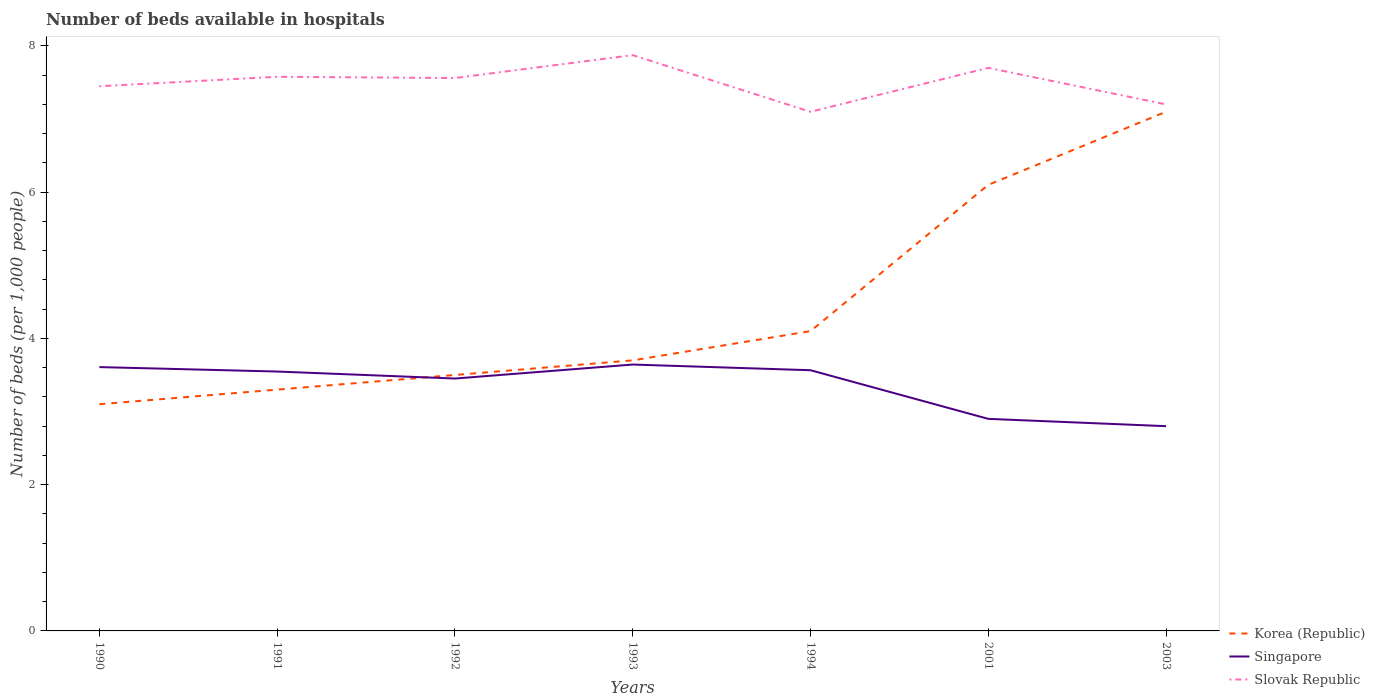How many different coloured lines are there?
Give a very brief answer. 3. Does the line corresponding to Korea (Republic) intersect with the line corresponding to Slovak Republic?
Your answer should be compact. No. Across all years, what is the maximum number of beds in the hospiatls of in Korea (Republic)?
Offer a very short reply. 3.1. In which year was the number of beds in the hospiatls of in Singapore maximum?
Provide a succinct answer. 2003. What is the total number of beds in the hospiatls of in Korea (Republic) in the graph?
Your answer should be compact. -0.8. What is the difference between the highest and the second highest number of beds in the hospiatls of in Slovak Republic?
Keep it short and to the point. 0.77. Are the values on the major ticks of Y-axis written in scientific E-notation?
Your answer should be compact. No. Does the graph contain grids?
Your response must be concise. No. Where does the legend appear in the graph?
Your response must be concise. Bottom right. How many legend labels are there?
Your answer should be very brief. 3. How are the legend labels stacked?
Give a very brief answer. Vertical. What is the title of the graph?
Provide a short and direct response. Number of beds available in hospitals. Does "Greece" appear as one of the legend labels in the graph?
Provide a succinct answer. No. What is the label or title of the X-axis?
Provide a short and direct response. Years. What is the label or title of the Y-axis?
Make the answer very short. Number of beds (per 1,0 people). What is the Number of beds (per 1,000 people) of Korea (Republic) in 1990?
Your answer should be very brief. 3.1. What is the Number of beds (per 1,000 people) of Singapore in 1990?
Offer a very short reply. 3.61. What is the Number of beds (per 1,000 people) in Slovak Republic in 1990?
Offer a terse response. 7.45. What is the Number of beds (per 1,000 people) of Korea (Republic) in 1991?
Provide a short and direct response. 3.3. What is the Number of beds (per 1,000 people) in Singapore in 1991?
Provide a short and direct response. 3.55. What is the Number of beds (per 1,000 people) in Slovak Republic in 1991?
Keep it short and to the point. 7.58. What is the Number of beds (per 1,000 people) of Korea (Republic) in 1992?
Make the answer very short. 3.5. What is the Number of beds (per 1,000 people) in Singapore in 1992?
Offer a very short reply. 3.45. What is the Number of beds (per 1,000 people) in Slovak Republic in 1992?
Your response must be concise. 7.56. What is the Number of beds (per 1,000 people) of Korea (Republic) in 1993?
Give a very brief answer. 3.7. What is the Number of beds (per 1,000 people) of Singapore in 1993?
Your answer should be compact. 3.64. What is the Number of beds (per 1,000 people) in Slovak Republic in 1993?
Give a very brief answer. 7.87. What is the Number of beds (per 1,000 people) of Korea (Republic) in 1994?
Your response must be concise. 4.1. What is the Number of beds (per 1,000 people) in Singapore in 1994?
Your answer should be very brief. 3.57. What is the Number of beds (per 1,000 people) in Slovak Republic in 1994?
Ensure brevity in your answer.  7.1. What is the Number of beds (per 1,000 people) in Korea (Republic) in 2001?
Provide a succinct answer. 6.1. What is the Number of beds (per 1,000 people) of Singapore in 2001?
Your answer should be very brief. 2.9. What is the Number of beds (per 1,000 people) of Slovak Republic in 2001?
Make the answer very short. 7.7. What is the Number of beds (per 1,000 people) in Korea (Republic) in 2003?
Make the answer very short. 7.1. What is the Number of beds (per 1,000 people) of Singapore in 2003?
Provide a short and direct response. 2.8. What is the Number of beds (per 1,000 people) of Slovak Republic in 2003?
Keep it short and to the point. 7.2. Across all years, what is the maximum Number of beds (per 1,000 people) in Korea (Republic)?
Give a very brief answer. 7.1. Across all years, what is the maximum Number of beds (per 1,000 people) of Singapore?
Your response must be concise. 3.64. Across all years, what is the maximum Number of beds (per 1,000 people) in Slovak Republic?
Your response must be concise. 7.87. Across all years, what is the minimum Number of beds (per 1,000 people) in Korea (Republic)?
Your response must be concise. 3.1. Across all years, what is the minimum Number of beds (per 1,000 people) in Singapore?
Ensure brevity in your answer.  2.8. Across all years, what is the minimum Number of beds (per 1,000 people) of Slovak Republic?
Offer a very short reply. 7.1. What is the total Number of beds (per 1,000 people) in Korea (Republic) in the graph?
Make the answer very short. 30.9. What is the total Number of beds (per 1,000 people) in Singapore in the graph?
Make the answer very short. 23.51. What is the total Number of beds (per 1,000 people) of Slovak Republic in the graph?
Keep it short and to the point. 52.46. What is the difference between the Number of beds (per 1,000 people) of Singapore in 1990 and that in 1991?
Your answer should be compact. 0.06. What is the difference between the Number of beds (per 1,000 people) in Slovak Republic in 1990 and that in 1991?
Your answer should be compact. -0.13. What is the difference between the Number of beds (per 1,000 people) in Singapore in 1990 and that in 1992?
Your answer should be very brief. 0.16. What is the difference between the Number of beds (per 1,000 people) of Slovak Republic in 1990 and that in 1992?
Provide a succinct answer. -0.11. What is the difference between the Number of beds (per 1,000 people) of Korea (Republic) in 1990 and that in 1993?
Offer a terse response. -0.6. What is the difference between the Number of beds (per 1,000 people) of Singapore in 1990 and that in 1993?
Offer a terse response. -0.03. What is the difference between the Number of beds (per 1,000 people) in Slovak Republic in 1990 and that in 1993?
Your answer should be very brief. -0.43. What is the difference between the Number of beds (per 1,000 people) in Singapore in 1990 and that in 1994?
Keep it short and to the point. 0.04. What is the difference between the Number of beds (per 1,000 people) in Slovak Republic in 1990 and that in 1994?
Offer a very short reply. 0.35. What is the difference between the Number of beds (per 1,000 people) in Singapore in 1990 and that in 2001?
Provide a short and direct response. 0.71. What is the difference between the Number of beds (per 1,000 people) of Slovak Republic in 1990 and that in 2001?
Give a very brief answer. -0.25. What is the difference between the Number of beds (per 1,000 people) of Singapore in 1990 and that in 2003?
Provide a short and direct response. 0.81. What is the difference between the Number of beds (per 1,000 people) in Slovak Republic in 1990 and that in 2003?
Offer a terse response. 0.25. What is the difference between the Number of beds (per 1,000 people) in Singapore in 1991 and that in 1992?
Keep it short and to the point. 0.1. What is the difference between the Number of beds (per 1,000 people) of Slovak Republic in 1991 and that in 1992?
Keep it short and to the point. 0.02. What is the difference between the Number of beds (per 1,000 people) in Korea (Republic) in 1991 and that in 1993?
Make the answer very short. -0.4. What is the difference between the Number of beds (per 1,000 people) in Singapore in 1991 and that in 1993?
Give a very brief answer. -0.1. What is the difference between the Number of beds (per 1,000 people) of Slovak Republic in 1991 and that in 1993?
Your answer should be very brief. -0.3. What is the difference between the Number of beds (per 1,000 people) in Singapore in 1991 and that in 1994?
Ensure brevity in your answer.  -0.02. What is the difference between the Number of beds (per 1,000 people) in Slovak Republic in 1991 and that in 1994?
Provide a succinct answer. 0.48. What is the difference between the Number of beds (per 1,000 people) in Singapore in 1991 and that in 2001?
Offer a very short reply. 0.65. What is the difference between the Number of beds (per 1,000 people) in Slovak Republic in 1991 and that in 2001?
Your answer should be compact. -0.12. What is the difference between the Number of beds (per 1,000 people) of Korea (Republic) in 1991 and that in 2003?
Provide a succinct answer. -3.8. What is the difference between the Number of beds (per 1,000 people) in Singapore in 1991 and that in 2003?
Keep it short and to the point. 0.75. What is the difference between the Number of beds (per 1,000 people) of Slovak Republic in 1991 and that in 2003?
Provide a short and direct response. 0.38. What is the difference between the Number of beds (per 1,000 people) of Korea (Republic) in 1992 and that in 1993?
Your answer should be compact. -0.2. What is the difference between the Number of beds (per 1,000 people) in Singapore in 1992 and that in 1993?
Make the answer very short. -0.19. What is the difference between the Number of beds (per 1,000 people) in Slovak Republic in 1992 and that in 1993?
Provide a short and direct response. -0.31. What is the difference between the Number of beds (per 1,000 people) of Singapore in 1992 and that in 1994?
Provide a succinct answer. -0.11. What is the difference between the Number of beds (per 1,000 people) of Slovak Republic in 1992 and that in 1994?
Provide a short and direct response. 0.46. What is the difference between the Number of beds (per 1,000 people) of Singapore in 1992 and that in 2001?
Provide a succinct answer. 0.55. What is the difference between the Number of beds (per 1,000 people) in Slovak Republic in 1992 and that in 2001?
Provide a succinct answer. -0.14. What is the difference between the Number of beds (per 1,000 people) in Korea (Republic) in 1992 and that in 2003?
Keep it short and to the point. -3.6. What is the difference between the Number of beds (per 1,000 people) of Singapore in 1992 and that in 2003?
Your answer should be compact. 0.65. What is the difference between the Number of beds (per 1,000 people) in Slovak Republic in 1992 and that in 2003?
Make the answer very short. 0.36. What is the difference between the Number of beds (per 1,000 people) in Singapore in 1993 and that in 1994?
Offer a very short reply. 0.08. What is the difference between the Number of beds (per 1,000 people) in Slovak Republic in 1993 and that in 1994?
Your answer should be very brief. 0.77. What is the difference between the Number of beds (per 1,000 people) in Singapore in 1993 and that in 2001?
Give a very brief answer. 0.74. What is the difference between the Number of beds (per 1,000 people) of Slovak Republic in 1993 and that in 2001?
Provide a succinct answer. 0.17. What is the difference between the Number of beds (per 1,000 people) in Korea (Republic) in 1993 and that in 2003?
Make the answer very short. -3.4. What is the difference between the Number of beds (per 1,000 people) in Singapore in 1993 and that in 2003?
Make the answer very short. 0.84. What is the difference between the Number of beds (per 1,000 people) of Slovak Republic in 1993 and that in 2003?
Keep it short and to the point. 0.67. What is the difference between the Number of beds (per 1,000 people) of Singapore in 1994 and that in 2001?
Provide a short and direct response. 0.67. What is the difference between the Number of beds (per 1,000 people) of Slovak Republic in 1994 and that in 2001?
Keep it short and to the point. -0.6. What is the difference between the Number of beds (per 1,000 people) in Korea (Republic) in 1994 and that in 2003?
Provide a succinct answer. -3. What is the difference between the Number of beds (per 1,000 people) in Singapore in 1994 and that in 2003?
Your answer should be very brief. 0.77. What is the difference between the Number of beds (per 1,000 people) in Slovak Republic in 1994 and that in 2003?
Provide a succinct answer. -0.1. What is the difference between the Number of beds (per 1,000 people) in Korea (Republic) in 2001 and that in 2003?
Make the answer very short. -1. What is the difference between the Number of beds (per 1,000 people) in Korea (Republic) in 1990 and the Number of beds (per 1,000 people) in Singapore in 1991?
Make the answer very short. -0.45. What is the difference between the Number of beds (per 1,000 people) in Korea (Republic) in 1990 and the Number of beds (per 1,000 people) in Slovak Republic in 1991?
Your response must be concise. -4.48. What is the difference between the Number of beds (per 1,000 people) in Singapore in 1990 and the Number of beds (per 1,000 people) in Slovak Republic in 1991?
Make the answer very short. -3.97. What is the difference between the Number of beds (per 1,000 people) of Korea (Republic) in 1990 and the Number of beds (per 1,000 people) of Singapore in 1992?
Offer a terse response. -0.35. What is the difference between the Number of beds (per 1,000 people) in Korea (Republic) in 1990 and the Number of beds (per 1,000 people) in Slovak Republic in 1992?
Give a very brief answer. -4.46. What is the difference between the Number of beds (per 1,000 people) of Singapore in 1990 and the Number of beds (per 1,000 people) of Slovak Republic in 1992?
Your answer should be very brief. -3.95. What is the difference between the Number of beds (per 1,000 people) in Korea (Republic) in 1990 and the Number of beds (per 1,000 people) in Singapore in 1993?
Ensure brevity in your answer.  -0.54. What is the difference between the Number of beds (per 1,000 people) of Korea (Republic) in 1990 and the Number of beds (per 1,000 people) of Slovak Republic in 1993?
Make the answer very short. -4.77. What is the difference between the Number of beds (per 1,000 people) of Singapore in 1990 and the Number of beds (per 1,000 people) of Slovak Republic in 1993?
Your response must be concise. -4.27. What is the difference between the Number of beds (per 1,000 people) in Korea (Republic) in 1990 and the Number of beds (per 1,000 people) in Singapore in 1994?
Offer a terse response. -0.47. What is the difference between the Number of beds (per 1,000 people) of Korea (Republic) in 1990 and the Number of beds (per 1,000 people) of Slovak Republic in 1994?
Ensure brevity in your answer.  -4. What is the difference between the Number of beds (per 1,000 people) of Singapore in 1990 and the Number of beds (per 1,000 people) of Slovak Republic in 1994?
Ensure brevity in your answer.  -3.49. What is the difference between the Number of beds (per 1,000 people) in Singapore in 1990 and the Number of beds (per 1,000 people) in Slovak Republic in 2001?
Keep it short and to the point. -4.09. What is the difference between the Number of beds (per 1,000 people) in Korea (Republic) in 1990 and the Number of beds (per 1,000 people) in Singapore in 2003?
Offer a very short reply. 0.3. What is the difference between the Number of beds (per 1,000 people) of Singapore in 1990 and the Number of beds (per 1,000 people) of Slovak Republic in 2003?
Your answer should be very brief. -3.59. What is the difference between the Number of beds (per 1,000 people) in Korea (Republic) in 1991 and the Number of beds (per 1,000 people) in Singapore in 1992?
Ensure brevity in your answer.  -0.15. What is the difference between the Number of beds (per 1,000 people) in Korea (Republic) in 1991 and the Number of beds (per 1,000 people) in Slovak Republic in 1992?
Ensure brevity in your answer.  -4.26. What is the difference between the Number of beds (per 1,000 people) of Singapore in 1991 and the Number of beds (per 1,000 people) of Slovak Republic in 1992?
Your answer should be very brief. -4.01. What is the difference between the Number of beds (per 1,000 people) of Korea (Republic) in 1991 and the Number of beds (per 1,000 people) of Singapore in 1993?
Ensure brevity in your answer.  -0.34. What is the difference between the Number of beds (per 1,000 people) in Korea (Republic) in 1991 and the Number of beds (per 1,000 people) in Slovak Republic in 1993?
Ensure brevity in your answer.  -4.57. What is the difference between the Number of beds (per 1,000 people) of Singapore in 1991 and the Number of beds (per 1,000 people) of Slovak Republic in 1993?
Keep it short and to the point. -4.33. What is the difference between the Number of beds (per 1,000 people) of Korea (Republic) in 1991 and the Number of beds (per 1,000 people) of Singapore in 1994?
Your answer should be very brief. -0.27. What is the difference between the Number of beds (per 1,000 people) in Korea (Republic) in 1991 and the Number of beds (per 1,000 people) in Slovak Republic in 1994?
Offer a terse response. -3.8. What is the difference between the Number of beds (per 1,000 people) in Singapore in 1991 and the Number of beds (per 1,000 people) in Slovak Republic in 1994?
Make the answer very short. -3.55. What is the difference between the Number of beds (per 1,000 people) in Korea (Republic) in 1991 and the Number of beds (per 1,000 people) in Singapore in 2001?
Keep it short and to the point. 0.4. What is the difference between the Number of beds (per 1,000 people) of Singapore in 1991 and the Number of beds (per 1,000 people) of Slovak Republic in 2001?
Your answer should be compact. -4.15. What is the difference between the Number of beds (per 1,000 people) in Korea (Republic) in 1991 and the Number of beds (per 1,000 people) in Singapore in 2003?
Make the answer very short. 0.5. What is the difference between the Number of beds (per 1,000 people) in Singapore in 1991 and the Number of beds (per 1,000 people) in Slovak Republic in 2003?
Give a very brief answer. -3.65. What is the difference between the Number of beds (per 1,000 people) of Korea (Republic) in 1992 and the Number of beds (per 1,000 people) of Singapore in 1993?
Your answer should be very brief. -0.14. What is the difference between the Number of beds (per 1,000 people) of Korea (Republic) in 1992 and the Number of beds (per 1,000 people) of Slovak Republic in 1993?
Provide a short and direct response. -4.37. What is the difference between the Number of beds (per 1,000 people) of Singapore in 1992 and the Number of beds (per 1,000 people) of Slovak Republic in 1993?
Offer a very short reply. -4.42. What is the difference between the Number of beds (per 1,000 people) of Korea (Republic) in 1992 and the Number of beds (per 1,000 people) of Singapore in 1994?
Provide a short and direct response. -0.07. What is the difference between the Number of beds (per 1,000 people) in Korea (Republic) in 1992 and the Number of beds (per 1,000 people) in Slovak Republic in 1994?
Your answer should be very brief. -3.6. What is the difference between the Number of beds (per 1,000 people) of Singapore in 1992 and the Number of beds (per 1,000 people) of Slovak Republic in 1994?
Ensure brevity in your answer.  -3.65. What is the difference between the Number of beds (per 1,000 people) in Korea (Republic) in 1992 and the Number of beds (per 1,000 people) in Singapore in 2001?
Make the answer very short. 0.6. What is the difference between the Number of beds (per 1,000 people) in Korea (Republic) in 1992 and the Number of beds (per 1,000 people) in Slovak Republic in 2001?
Your response must be concise. -4.2. What is the difference between the Number of beds (per 1,000 people) in Singapore in 1992 and the Number of beds (per 1,000 people) in Slovak Republic in 2001?
Keep it short and to the point. -4.25. What is the difference between the Number of beds (per 1,000 people) in Singapore in 1992 and the Number of beds (per 1,000 people) in Slovak Republic in 2003?
Your answer should be very brief. -3.75. What is the difference between the Number of beds (per 1,000 people) in Korea (Republic) in 1993 and the Number of beds (per 1,000 people) in Singapore in 1994?
Provide a short and direct response. 0.13. What is the difference between the Number of beds (per 1,000 people) in Korea (Republic) in 1993 and the Number of beds (per 1,000 people) in Slovak Republic in 1994?
Your answer should be compact. -3.4. What is the difference between the Number of beds (per 1,000 people) in Singapore in 1993 and the Number of beds (per 1,000 people) in Slovak Republic in 1994?
Your answer should be compact. -3.46. What is the difference between the Number of beds (per 1,000 people) in Korea (Republic) in 1993 and the Number of beds (per 1,000 people) in Singapore in 2001?
Offer a terse response. 0.8. What is the difference between the Number of beds (per 1,000 people) of Korea (Republic) in 1993 and the Number of beds (per 1,000 people) of Slovak Republic in 2001?
Provide a succinct answer. -4. What is the difference between the Number of beds (per 1,000 people) of Singapore in 1993 and the Number of beds (per 1,000 people) of Slovak Republic in 2001?
Your response must be concise. -4.06. What is the difference between the Number of beds (per 1,000 people) in Korea (Republic) in 1993 and the Number of beds (per 1,000 people) in Singapore in 2003?
Provide a succinct answer. 0.9. What is the difference between the Number of beds (per 1,000 people) of Korea (Republic) in 1993 and the Number of beds (per 1,000 people) of Slovak Republic in 2003?
Keep it short and to the point. -3.5. What is the difference between the Number of beds (per 1,000 people) in Singapore in 1993 and the Number of beds (per 1,000 people) in Slovak Republic in 2003?
Offer a terse response. -3.56. What is the difference between the Number of beds (per 1,000 people) of Korea (Republic) in 1994 and the Number of beds (per 1,000 people) of Slovak Republic in 2001?
Give a very brief answer. -3.6. What is the difference between the Number of beds (per 1,000 people) in Singapore in 1994 and the Number of beds (per 1,000 people) in Slovak Republic in 2001?
Give a very brief answer. -4.13. What is the difference between the Number of beds (per 1,000 people) of Singapore in 1994 and the Number of beds (per 1,000 people) of Slovak Republic in 2003?
Your answer should be compact. -3.63. What is the difference between the Number of beds (per 1,000 people) in Korea (Republic) in 2001 and the Number of beds (per 1,000 people) in Slovak Republic in 2003?
Give a very brief answer. -1.1. What is the average Number of beds (per 1,000 people) in Korea (Republic) per year?
Offer a terse response. 4.41. What is the average Number of beds (per 1,000 people) of Singapore per year?
Provide a short and direct response. 3.36. What is the average Number of beds (per 1,000 people) in Slovak Republic per year?
Provide a short and direct response. 7.49. In the year 1990, what is the difference between the Number of beds (per 1,000 people) of Korea (Republic) and Number of beds (per 1,000 people) of Singapore?
Offer a very short reply. -0.51. In the year 1990, what is the difference between the Number of beds (per 1,000 people) of Korea (Republic) and Number of beds (per 1,000 people) of Slovak Republic?
Keep it short and to the point. -4.35. In the year 1990, what is the difference between the Number of beds (per 1,000 people) in Singapore and Number of beds (per 1,000 people) in Slovak Republic?
Your answer should be very brief. -3.84. In the year 1991, what is the difference between the Number of beds (per 1,000 people) in Korea (Republic) and Number of beds (per 1,000 people) in Singapore?
Provide a succinct answer. -0.25. In the year 1991, what is the difference between the Number of beds (per 1,000 people) in Korea (Republic) and Number of beds (per 1,000 people) in Slovak Republic?
Ensure brevity in your answer.  -4.28. In the year 1991, what is the difference between the Number of beds (per 1,000 people) of Singapore and Number of beds (per 1,000 people) of Slovak Republic?
Your answer should be compact. -4.03. In the year 1992, what is the difference between the Number of beds (per 1,000 people) in Korea (Republic) and Number of beds (per 1,000 people) in Singapore?
Make the answer very short. 0.05. In the year 1992, what is the difference between the Number of beds (per 1,000 people) in Korea (Republic) and Number of beds (per 1,000 people) in Slovak Republic?
Offer a very short reply. -4.06. In the year 1992, what is the difference between the Number of beds (per 1,000 people) of Singapore and Number of beds (per 1,000 people) of Slovak Republic?
Your answer should be compact. -4.11. In the year 1993, what is the difference between the Number of beds (per 1,000 people) of Korea (Republic) and Number of beds (per 1,000 people) of Singapore?
Offer a very short reply. 0.06. In the year 1993, what is the difference between the Number of beds (per 1,000 people) of Korea (Republic) and Number of beds (per 1,000 people) of Slovak Republic?
Offer a terse response. -4.17. In the year 1993, what is the difference between the Number of beds (per 1,000 people) of Singapore and Number of beds (per 1,000 people) of Slovak Republic?
Provide a succinct answer. -4.23. In the year 1994, what is the difference between the Number of beds (per 1,000 people) of Korea (Republic) and Number of beds (per 1,000 people) of Singapore?
Offer a very short reply. 0.53. In the year 1994, what is the difference between the Number of beds (per 1,000 people) of Korea (Republic) and Number of beds (per 1,000 people) of Slovak Republic?
Offer a terse response. -3. In the year 1994, what is the difference between the Number of beds (per 1,000 people) of Singapore and Number of beds (per 1,000 people) of Slovak Republic?
Ensure brevity in your answer.  -3.53. In the year 2001, what is the difference between the Number of beds (per 1,000 people) in Korea (Republic) and Number of beds (per 1,000 people) in Singapore?
Your response must be concise. 3.2. In the year 2001, what is the difference between the Number of beds (per 1,000 people) in Korea (Republic) and Number of beds (per 1,000 people) in Slovak Republic?
Your answer should be very brief. -1.6. In the year 2003, what is the difference between the Number of beds (per 1,000 people) in Korea (Republic) and Number of beds (per 1,000 people) in Slovak Republic?
Your response must be concise. -0.1. In the year 2003, what is the difference between the Number of beds (per 1,000 people) of Singapore and Number of beds (per 1,000 people) of Slovak Republic?
Offer a very short reply. -4.4. What is the ratio of the Number of beds (per 1,000 people) of Korea (Republic) in 1990 to that in 1991?
Your answer should be very brief. 0.94. What is the ratio of the Number of beds (per 1,000 people) of Singapore in 1990 to that in 1991?
Ensure brevity in your answer.  1.02. What is the ratio of the Number of beds (per 1,000 people) in Slovak Republic in 1990 to that in 1991?
Your answer should be compact. 0.98. What is the ratio of the Number of beds (per 1,000 people) in Korea (Republic) in 1990 to that in 1992?
Your response must be concise. 0.89. What is the ratio of the Number of beds (per 1,000 people) in Singapore in 1990 to that in 1992?
Offer a very short reply. 1.05. What is the ratio of the Number of beds (per 1,000 people) in Slovak Republic in 1990 to that in 1992?
Offer a terse response. 0.99. What is the ratio of the Number of beds (per 1,000 people) of Korea (Republic) in 1990 to that in 1993?
Make the answer very short. 0.84. What is the ratio of the Number of beds (per 1,000 people) of Singapore in 1990 to that in 1993?
Your answer should be compact. 0.99. What is the ratio of the Number of beds (per 1,000 people) in Slovak Republic in 1990 to that in 1993?
Ensure brevity in your answer.  0.95. What is the ratio of the Number of beds (per 1,000 people) in Korea (Republic) in 1990 to that in 1994?
Provide a short and direct response. 0.76. What is the ratio of the Number of beds (per 1,000 people) in Singapore in 1990 to that in 1994?
Offer a terse response. 1.01. What is the ratio of the Number of beds (per 1,000 people) in Slovak Republic in 1990 to that in 1994?
Your answer should be compact. 1.05. What is the ratio of the Number of beds (per 1,000 people) in Korea (Republic) in 1990 to that in 2001?
Give a very brief answer. 0.51. What is the ratio of the Number of beds (per 1,000 people) in Singapore in 1990 to that in 2001?
Your answer should be compact. 1.24. What is the ratio of the Number of beds (per 1,000 people) of Slovak Republic in 1990 to that in 2001?
Make the answer very short. 0.97. What is the ratio of the Number of beds (per 1,000 people) of Korea (Republic) in 1990 to that in 2003?
Your answer should be very brief. 0.44. What is the ratio of the Number of beds (per 1,000 people) of Singapore in 1990 to that in 2003?
Provide a short and direct response. 1.29. What is the ratio of the Number of beds (per 1,000 people) in Slovak Republic in 1990 to that in 2003?
Provide a succinct answer. 1.03. What is the ratio of the Number of beds (per 1,000 people) in Korea (Republic) in 1991 to that in 1992?
Your answer should be very brief. 0.94. What is the ratio of the Number of beds (per 1,000 people) of Singapore in 1991 to that in 1992?
Offer a terse response. 1.03. What is the ratio of the Number of beds (per 1,000 people) of Korea (Republic) in 1991 to that in 1993?
Ensure brevity in your answer.  0.89. What is the ratio of the Number of beds (per 1,000 people) in Singapore in 1991 to that in 1993?
Keep it short and to the point. 0.97. What is the ratio of the Number of beds (per 1,000 people) in Slovak Republic in 1991 to that in 1993?
Ensure brevity in your answer.  0.96. What is the ratio of the Number of beds (per 1,000 people) in Korea (Republic) in 1991 to that in 1994?
Keep it short and to the point. 0.8. What is the ratio of the Number of beds (per 1,000 people) in Slovak Republic in 1991 to that in 1994?
Your answer should be very brief. 1.07. What is the ratio of the Number of beds (per 1,000 people) of Korea (Republic) in 1991 to that in 2001?
Offer a very short reply. 0.54. What is the ratio of the Number of beds (per 1,000 people) of Singapore in 1991 to that in 2001?
Ensure brevity in your answer.  1.22. What is the ratio of the Number of beds (per 1,000 people) in Slovak Republic in 1991 to that in 2001?
Ensure brevity in your answer.  0.98. What is the ratio of the Number of beds (per 1,000 people) in Korea (Republic) in 1991 to that in 2003?
Ensure brevity in your answer.  0.46. What is the ratio of the Number of beds (per 1,000 people) in Singapore in 1991 to that in 2003?
Your response must be concise. 1.27. What is the ratio of the Number of beds (per 1,000 people) of Slovak Republic in 1991 to that in 2003?
Make the answer very short. 1.05. What is the ratio of the Number of beds (per 1,000 people) of Korea (Republic) in 1992 to that in 1993?
Your answer should be very brief. 0.95. What is the ratio of the Number of beds (per 1,000 people) of Singapore in 1992 to that in 1993?
Your answer should be compact. 0.95. What is the ratio of the Number of beds (per 1,000 people) in Slovak Republic in 1992 to that in 1993?
Keep it short and to the point. 0.96. What is the ratio of the Number of beds (per 1,000 people) of Korea (Republic) in 1992 to that in 1994?
Offer a very short reply. 0.85. What is the ratio of the Number of beds (per 1,000 people) of Singapore in 1992 to that in 1994?
Ensure brevity in your answer.  0.97. What is the ratio of the Number of beds (per 1,000 people) in Slovak Republic in 1992 to that in 1994?
Offer a very short reply. 1.06. What is the ratio of the Number of beds (per 1,000 people) in Korea (Republic) in 1992 to that in 2001?
Provide a short and direct response. 0.57. What is the ratio of the Number of beds (per 1,000 people) in Singapore in 1992 to that in 2001?
Give a very brief answer. 1.19. What is the ratio of the Number of beds (per 1,000 people) in Slovak Republic in 1992 to that in 2001?
Provide a succinct answer. 0.98. What is the ratio of the Number of beds (per 1,000 people) in Korea (Republic) in 1992 to that in 2003?
Offer a very short reply. 0.49. What is the ratio of the Number of beds (per 1,000 people) in Singapore in 1992 to that in 2003?
Ensure brevity in your answer.  1.23. What is the ratio of the Number of beds (per 1,000 people) of Slovak Republic in 1992 to that in 2003?
Make the answer very short. 1.05. What is the ratio of the Number of beds (per 1,000 people) of Korea (Republic) in 1993 to that in 1994?
Your answer should be very brief. 0.9. What is the ratio of the Number of beds (per 1,000 people) of Singapore in 1993 to that in 1994?
Offer a very short reply. 1.02. What is the ratio of the Number of beds (per 1,000 people) of Slovak Republic in 1993 to that in 1994?
Your response must be concise. 1.11. What is the ratio of the Number of beds (per 1,000 people) in Korea (Republic) in 1993 to that in 2001?
Your answer should be compact. 0.61. What is the ratio of the Number of beds (per 1,000 people) in Singapore in 1993 to that in 2001?
Keep it short and to the point. 1.26. What is the ratio of the Number of beds (per 1,000 people) in Slovak Republic in 1993 to that in 2001?
Give a very brief answer. 1.02. What is the ratio of the Number of beds (per 1,000 people) of Korea (Republic) in 1993 to that in 2003?
Your answer should be compact. 0.52. What is the ratio of the Number of beds (per 1,000 people) of Singapore in 1993 to that in 2003?
Ensure brevity in your answer.  1.3. What is the ratio of the Number of beds (per 1,000 people) of Slovak Republic in 1993 to that in 2003?
Keep it short and to the point. 1.09. What is the ratio of the Number of beds (per 1,000 people) in Korea (Republic) in 1994 to that in 2001?
Ensure brevity in your answer.  0.67. What is the ratio of the Number of beds (per 1,000 people) of Singapore in 1994 to that in 2001?
Provide a succinct answer. 1.23. What is the ratio of the Number of beds (per 1,000 people) of Slovak Republic in 1994 to that in 2001?
Offer a terse response. 0.92. What is the ratio of the Number of beds (per 1,000 people) of Korea (Republic) in 1994 to that in 2003?
Your answer should be compact. 0.58. What is the ratio of the Number of beds (per 1,000 people) of Singapore in 1994 to that in 2003?
Make the answer very short. 1.27. What is the ratio of the Number of beds (per 1,000 people) of Slovak Republic in 1994 to that in 2003?
Offer a very short reply. 0.99. What is the ratio of the Number of beds (per 1,000 people) of Korea (Republic) in 2001 to that in 2003?
Provide a short and direct response. 0.86. What is the ratio of the Number of beds (per 1,000 people) of Singapore in 2001 to that in 2003?
Your answer should be compact. 1.04. What is the ratio of the Number of beds (per 1,000 people) of Slovak Republic in 2001 to that in 2003?
Provide a succinct answer. 1.07. What is the difference between the highest and the second highest Number of beds (per 1,000 people) of Korea (Republic)?
Keep it short and to the point. 1. What is the difference between the highest and the second highest Number of beds (per 1,000 people) in Singapore?
Ensure brevity in your answer.  0.03. What is the difference between the highest and the second highest Number of beds (per 1,000 people) of Slovak Republic?
Give a very brief answer. 0.17. What is the difference between the highest and the lowest Number of beds (per 1,000 people) in Singapore?
Give a very brief answer. 0.84. What is the difference between the highest and the lowest Number of beds (per 1,000 people) in Slovak Republic?
Ensure brevity in your answer.  0.77. 